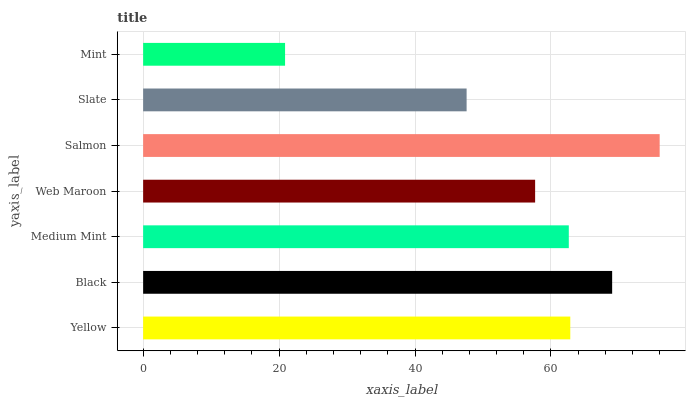Is Mint the minimum?
Answer yes or no. Yes. Is Salmon the maximum?
Answer yes or no. Yes. Is Black the minimum?
Answer yes or no. No. Is Black the maximum?
Answer yes or no. No. Is Black greater than Yellow?
Answer yes or no. Yes. Is Yellow less than Black?
Answer yes or no. Yes. Is Yellow greater than Black?
Answer yes or no. No. Is Black less than Yellow?
Answer yes or no. No. Is Medium Mint the high median?
Answer yes or no. Yes. Is Medium Mint the low median?
Answer yes or no. Yes. Is Black the high median?
Answer yes or no. No. Is Web Maroon the low median?
Answer yes or no. No. 